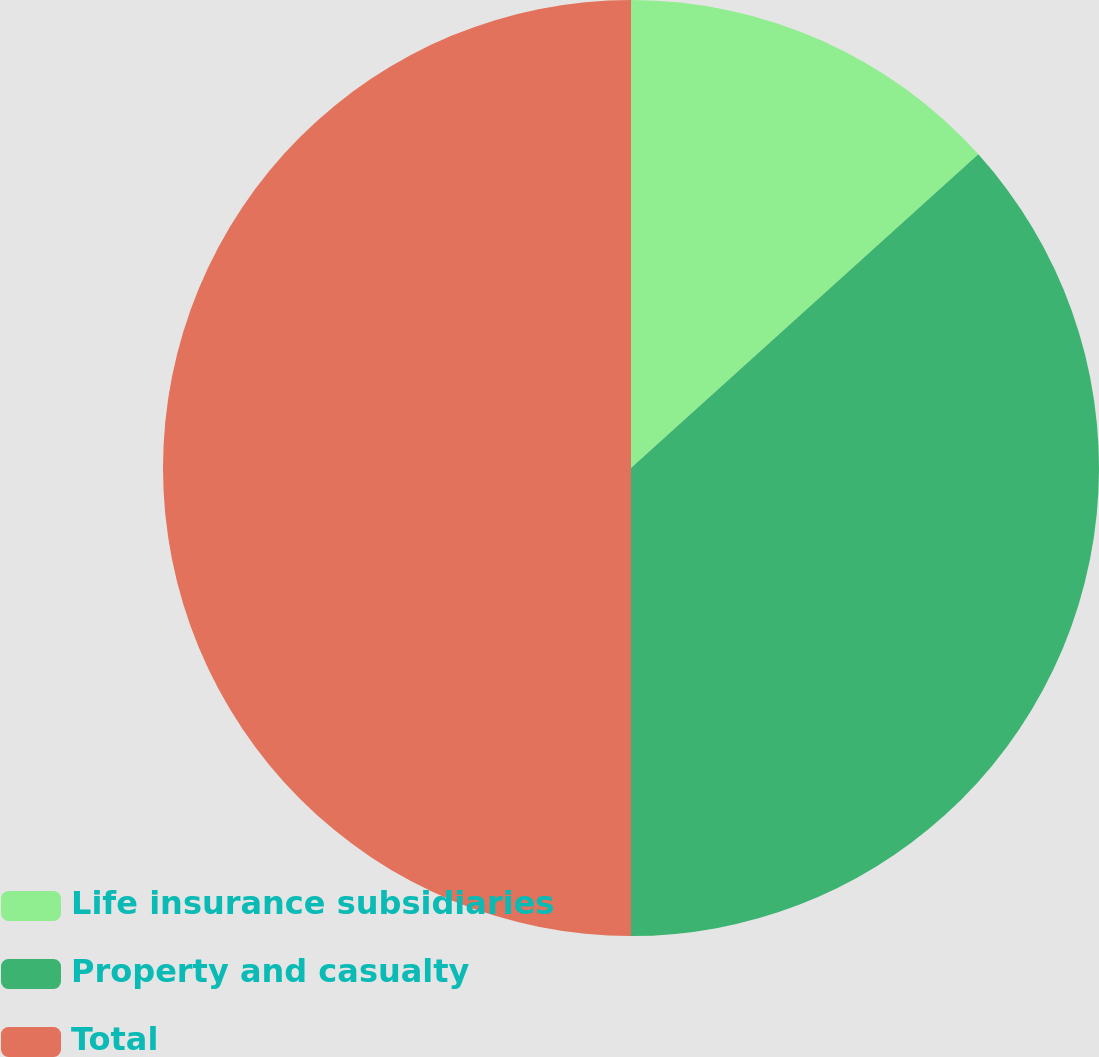<chart> <loc_0><loc_0><loc_500><loc_500><pie_chart><fcel>Life insurance subsidiaries<fcel>Property and casualty<fcel>Total<nl><fcel>13.31%<fcel>36.69%<fcel>50.0%<nl></chart> 